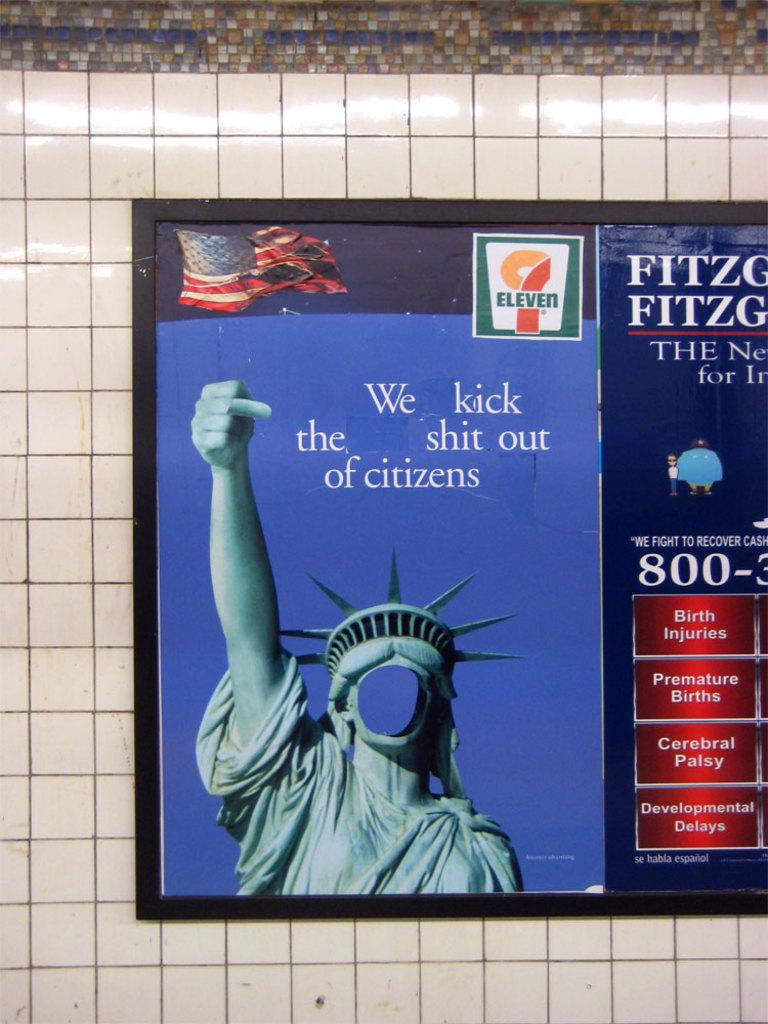<image>
Offer a succinct explanation of the picture presented. An advertisement for 7 Eleven showing a tattered flag and The Statue Of Liberty. 